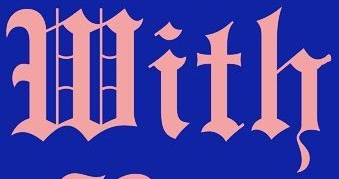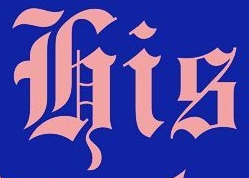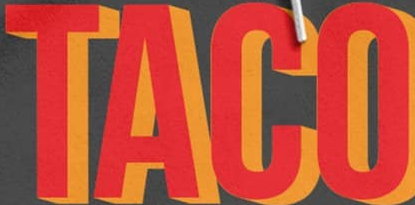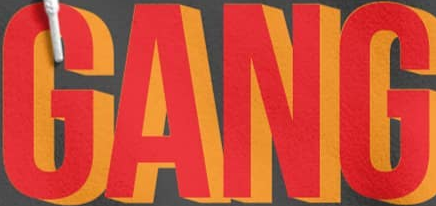Transcribe the words shown in these images in order, separated by a semicolon. With; His; TACO; GANG 